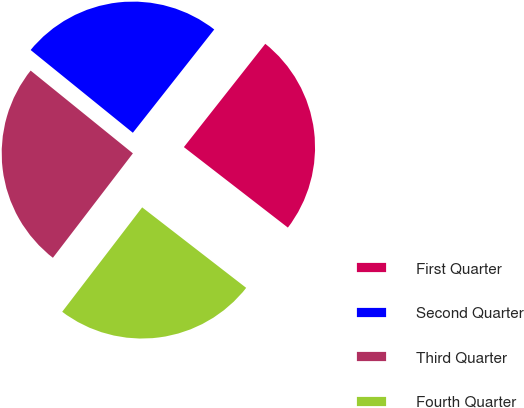Convert chart to OTSL. <chart><loc_0><loc_0><loc_500><loc_500><pie_chart><fcel>First Quarter<fcel>Second Quarter<fcel>Third Quarter<fcel>Fourth Quarter<nl><fcel>24.86%<fcel>24.79%<fcel>25.43%<fcel>24.92%<nl></chart> 